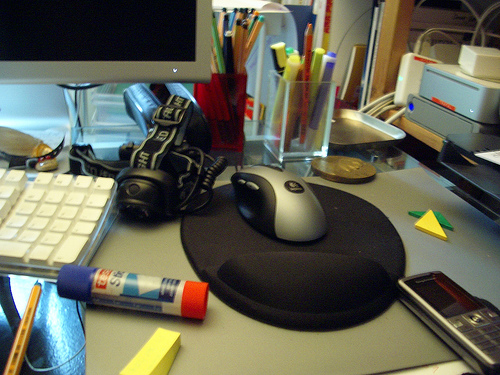<image>
Is there a mouse in the pad? No. The mouse is not contained within the pad. These objects have a different spatial relationship. 